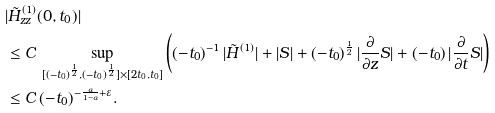Convert formula to latex. <formula><loc_0><loc_0><loc_500><loc_500>& | \tilde { H } ^ { ( 1 ) } _ { z z } ( 0 , t _ { 0 } ) | \\ & \leq C \, \sup _ { [ ( - t _ { 0 } ) ^ { \frac { 1 } { 2 } } , ( - t _ { 0 } ) ^ { \frac { 1 } { 2 } } ] \times [ 2 t _ { 0 } , t _ { 0 } ] } \left ( ( - t _ { 0 } ) ^ { - 1 } \, | \tilde { H } ^ { ( 1 ) } | + | S | + ( - t _ { 0 } ) ^ { \frac { 1 } { 2 } } \, | \frac { \partial } { \partial z } S | + ( - t _ { 0 } ) \, | \frac { \partial } { \partial t } S | \right ) \\ & \leq C \, ( - t _ { 0 } ) ^ { - \frac { \alpha } { 1 - \alpha } + \varepsilon } .</formula> 